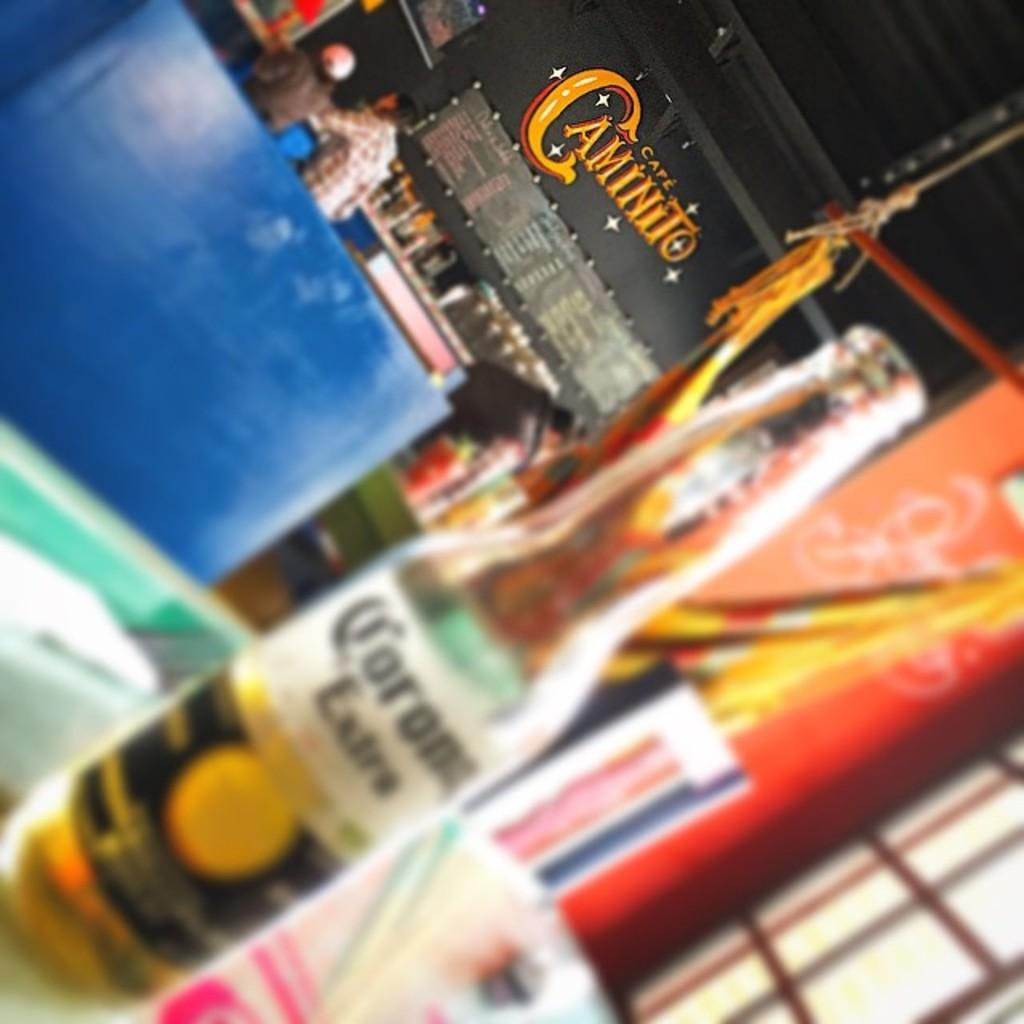<image>
Summarize the visual content of the image. An out of focus bottle of Corona Extra sitting on a table at Cafe Caminito. 